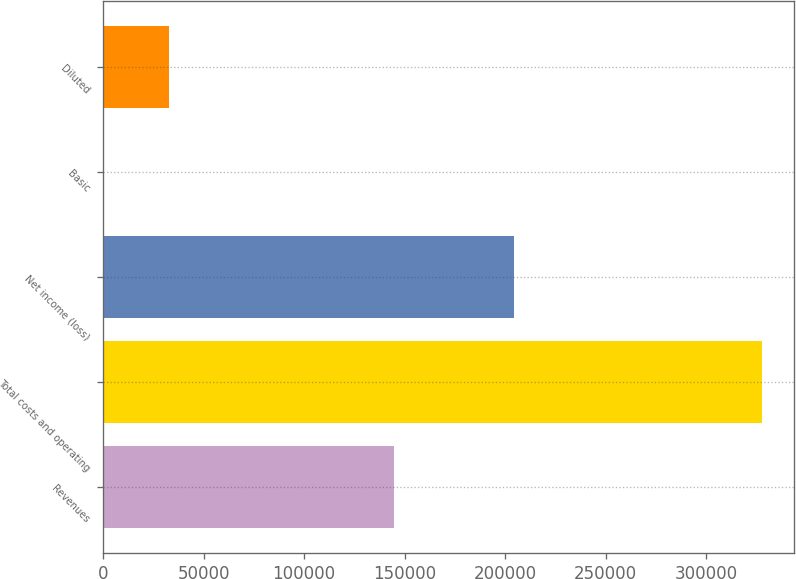<chart> <loc_0><loc_0><loc_500><loc_500><bar_chart><fcel>Revenues<fcel>Total costs and operating<fcel>Net income (loss)<fcel>Basic<fcel>Diluted<nl><fcel>144976<fcel>327580<fcel>204437<fcel>1.81<fcel>32759.6<nl></chart> 